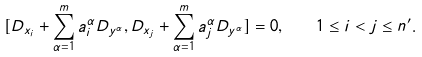Convert formula to latex. <formula><loc_0><loc_0><loc_500><loc_500>[ D _ { x _ { i } } + \sum _ { \alpha = 1 } ^ { m } a _ { i } ^ { \alpha } D _ { y ^ { \alpha } } , D _ { x _ { j } } + \sum _ { \alpha = 1 } ^ { m } a _ { j } ^ { \alpha } D _ { y ^ { \alpha } } ] = 0 , \quad 1 \leq i < j \leq n ^ { \prime } .</formula> 